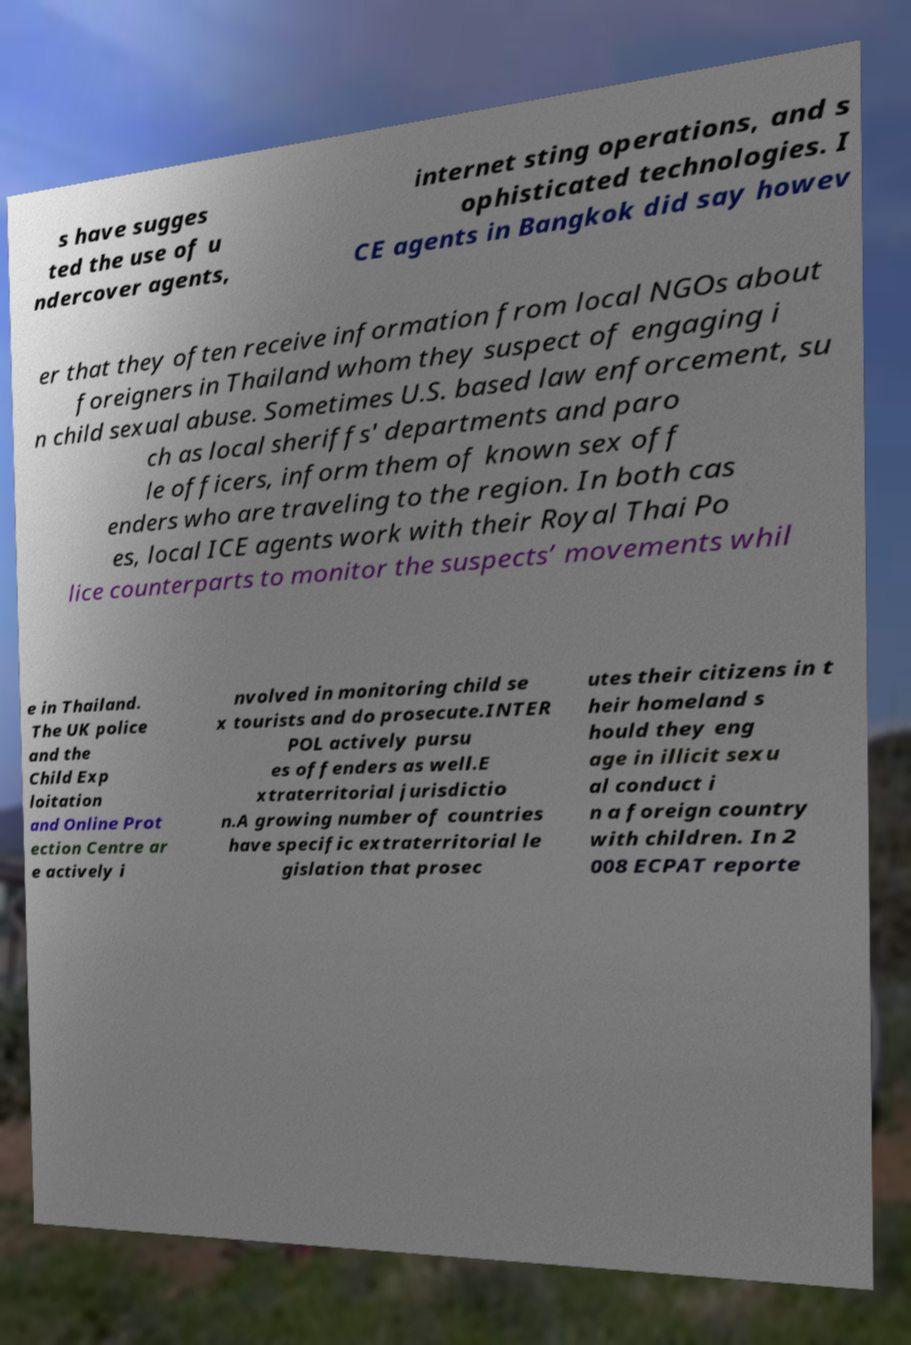I need the written content from this picture converted into text. Can you do that? s have sugges ted the use of u ndercover agents, internet sting operations, and s ophisticated technologies. I CE agents in Bangkok did say howev er that they often receive information from local NGOs about foreigners in Thailand whom they suspect of engaging i n child sexual abuse. Sometimes U.S. based law enforcement, su ch as local sheriffs' departments and paro le officers, inform them of known sex off enders who are traveling to the region. In both cas es, local ICE agents work with their Royal Thai Po lice counterparts to monitor the suspects’ movements whil e in Thailand. The UK police and the Child Exp loitation and Online Prot ection Centre ar e actively i nvolved in monitoring child se x tourists and do prosecute.INTER POL actively pursu es offenders as well.E xtraterritorial jurisdictio n.A growing number of countries have specific extraterritorial le gislation that prosec utes their citizens in t heir homeland s hould they eng age in illicit sexu al conduct i n a foreign country with children. In 2 008 ECPAT reporte 